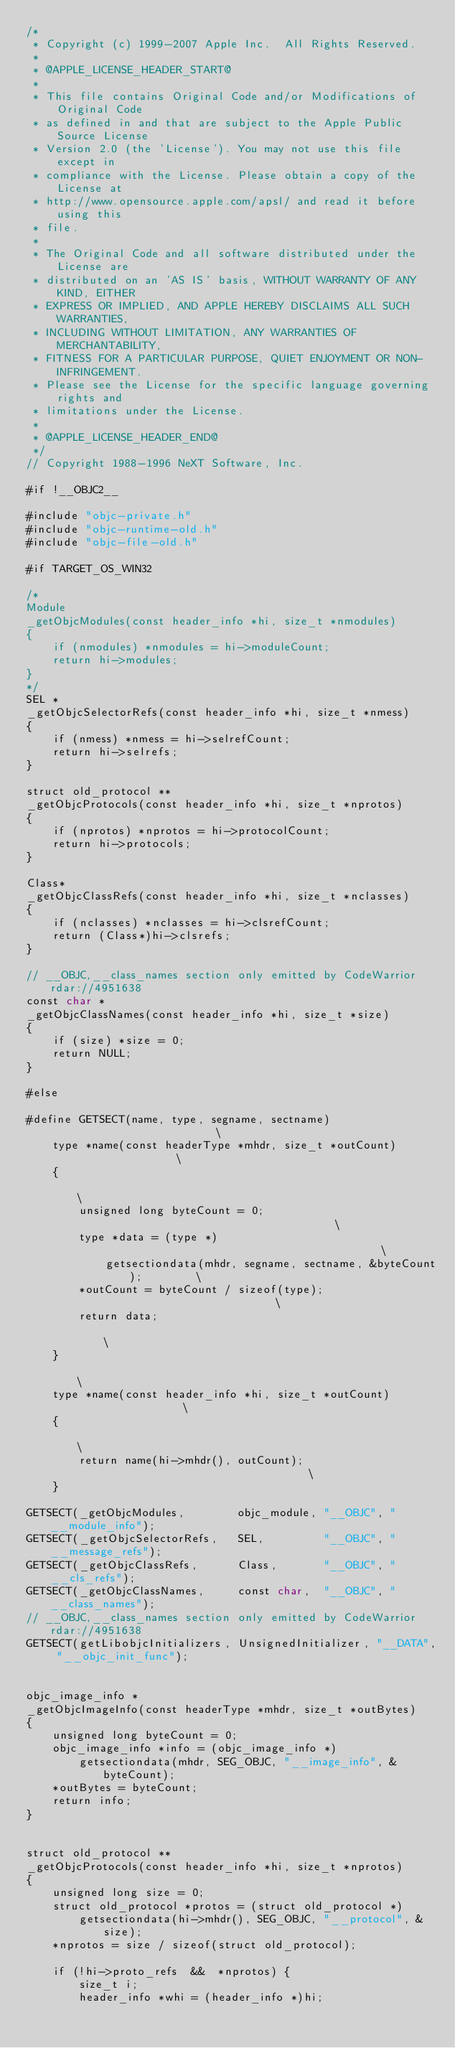Convert code to text. <code><loc_0><loc_0><loc_500><loc_500><_ObjectiveC_>/*
 * Copyright (c) 1999-2007 Apple Inc.  All Rights Reserved.
 * 
 * @APPLE_LICENSE_HEADER_START@
 * 
 * This file contains Original Code and/or Modifications of Original Code
 * as defined in and that are subject to the Apple Public Source License
 * Version 2.0 (the 'License'). You may not use this file except in
 * compliance with the License. Please obtain a copy of the License at
 * http://www.opensource.apple.com/apsl/ and read it before using this
 * file.
 * 
 * The Original Code and all software distributed under the License are
 * distributed on an 'AS IS' basis, WITHOUT WARRANTY OF ANY KIND, EITHER
 * EXPRESS OR IMPLIED, AND APPLE HEREBY DISCLAIMS ALL SUCH WARRANTIES,
 * INCLUDING WITHOUT LIMITATION, ANY WARRANTIES OF MERCHANTABILITY,
 * FITNESS FOR A PARTICULAR PURPOSE, QUIET ENJOYMENT OR NON-INFRINGEMENT.
 * Please see the License for the specific language governing rights and
 * limitations under the License.
 * 
 * @APPLE_LICENSE_HEADER_END@
 */
// Copyright 1988-1996 NeXT Software, Inc.

#if !__OBJC2__

#include "objc-private.h"
#include "objc-runtime-old.h"
#include "objc-file-old.h"

#if TARGET_OS_WIN32

/*
Module 
_getObjcModules(const header_info *hi, size_t *nmodules)
{
    if (nmodules) *nmodules = hi->moduleCount;
    return hi->modules;
}
*/
SEL *
_getObjcSelectorRefs(const header_info *hi, size_t *nmess)
{
    if (nmess) *nmess = hi->selrefCount;
    return hi->selrefs;
}

struct old_protocol **
_getObjcProtocols(const header_info *hi, size_t *nprotos)
{
    if (nprotos) *nprotos = hi->protocolCount;
    return hi->protocols;
}

Class*
_getObjcClassRefs(const header_info *hi, size_t *nclasses)
{
    if (nclasses) *nclasses = hi->clsrefCount;
    return (Class*)hi->clsrefs;
}

// __OBJC,__class_names section only emitted by CodeWarrior  rdar://4951638
const char *
_getObjcClassNames(const header_info *hi, size_t *size)
{
    if (size) *size = 0;
    return NULL;
}

#else

#define GETSECT(name, type, segname, sectname)                          \
    type *name(const headerType *mhdr, size_t *outCount)                \
    {                                                                   \
        unsigned long byteCount = 0;                                    \
        type *data = (type *)                                           \
            getsectiondata(mhdr, segname, sectname, &byteCount);        \
        *outCount = byteCount / sizeof(type);                           \
        return data;                                                    \
    }                                                                   \
    type *name(const header_info *hi, size_t *outCount)                 \
    {                                                                   \
        return name(hi->mhdr(), outCount);                                \
    }

GETSECT(_getObjcModules,        objc_module, "__OBJC", "__module_info");
GETSECT(_getObjcSelectorRefs,   SEL,         "__OBJC", "__message_refs");
GETSECT(_getObjcClassRefs,      Class,       "__OBJC", "__cls_refs");
GETSECT(_getObjcClassNames,     const char,  "__OBJC", "__class_names");
// __OBJC,__class_names section only emitted by CodeWarrior  rdar://4951638
GETSECT(getLibobjcInitializers, UnsignedInitializer, "__DATA", "__objc_init_func");


objc_image_info *
_getObjcImageInfo(const headerType *mhdr, size_t *outBytes)
{
    unsigned long byteCount = 0;
    objc_image_info *info = (objc_image_info *)
        getsectiondata(mhdr, SEG_OBJC, "__image_info", &byteCount);
    *outBytes = byteCount;
    return info;
}


struct old_protocol **
_getObjcProtocols(const header_info *hi, size_t *nprotos)
{
    unsigned long size = 0;
    struct old_protocol *protos = (struct old_protocol *)
        getsectiondata(hi->mhdr(), SEG_OBJC, "__protocol", &size);
    *nprotos = size / sizeof(struct old_protocol);
    
    if (!hi->proto_refs  &&  *nprotos) {
        size_t i;
        header_info *whi = (header_info *)hi;</code> 